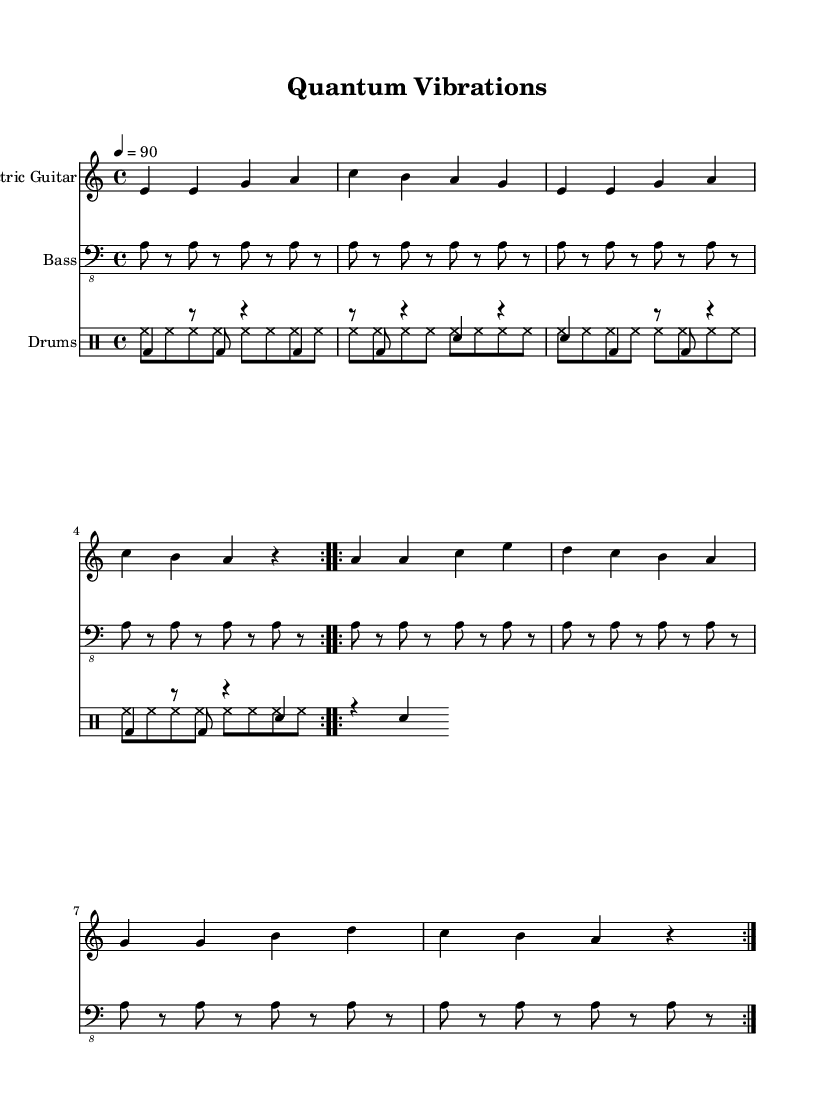What is the key signature of this music? The key signature indicates the tonality of the piece, which is defined by the number of sharps or flats present. In this music sheet, the "a" key signature indicates that there is one flat (B♭), making it A minor.
Answer: A minor What is the time signature of this music? The time signature is found next to the clefs and indicates how many beats are in a measure and what note value gets the beat. Here, 4/4 time means there are four beats per measure with the quarter note receiving one beat.
Answer: 4/4 What is the tempo marking for this piece? The tempo marking, located above the staff, indicates the speed or pace of the music. The marking states "4 = 90," which means there are 90 beats per minute.
Answer: 90 What instruments are indicated in the score? The instruments are specified at the beginning of each staff. The score shows an "Electric Guitar," "Bass," and "Drums." Combining this information, we can summarize the instruments in the piece.
Answer: Electric Guitar, Bass, Drums How many times does the electric guitar repeat its first section? In the electric guitar part, there’s a clear indication of a repeat sign (volta) at the beginning of the first section, which shows that this section should be played twice.
Answer: 2 What rhythmic elements are used in the drum part? The drum part includes pitched bass drums denoted as "bd" and unpitched hi-hats noted as "hh". The repeated patterns show how these two elements create the reggae feel.
Answer: Bass drum, Hi-hat How does the bass guitar contribute to the overall reggae feel? The bass guitar is playing a continuous pattern using mostly eighth notes, while it also provides rhythmic support by following the pulse of the music, which is a characteristic element of reggae music.
Answer: Continuous eighth-note pattern 